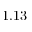Convert formula to latex. <formula><loc_0><loc_0><loc_500><loc_500>1 . 1 3</formula> 